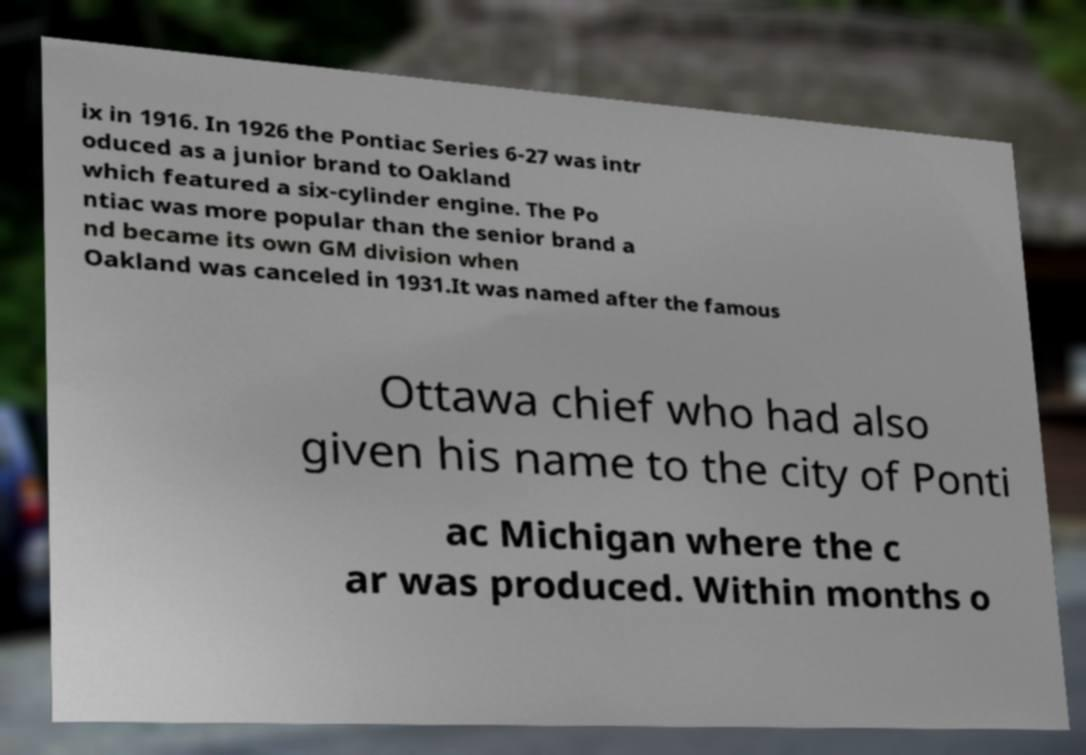What messages or text are displayed in this image? I need them in a readable, typed format. ix in 1916. In 1926 the Pontiac Series 6-27 was intr oduced as a junior brand to Oakland which featured a six-cylinder engine. The Po ntiac was more popular than the senior brand a nd became its own GM division when Oakland was canceled in 1931.It was named after the famous Ottawa chief who had also given his name to the city of Ponti ac Michigan where the c ar was produced. Within months o 